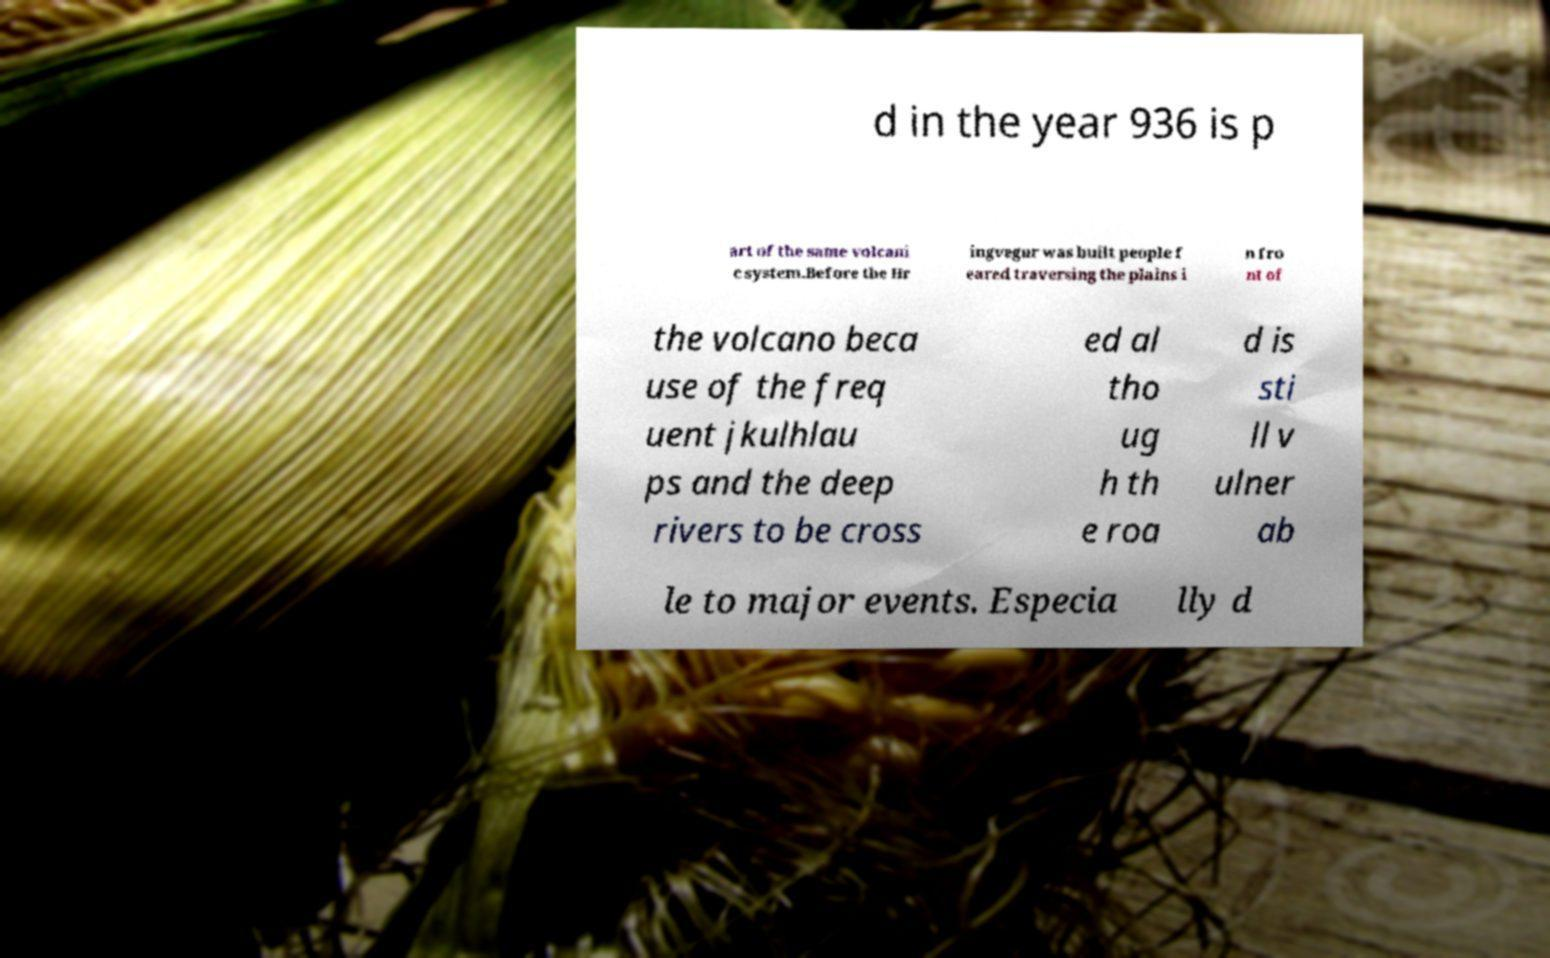Can you read and provide the text displayed in the image?This photo seems to have some interesting text. Can you extract and type it out for me? d in the year 936 is p art of the same volcani c system.Before the Hr ingvegur was built people f eared traversing the plains i n fro nt of the volcano beca use of the freq uent jkulhlau ps and the deep rivers to be cross ed al tho ug h th e roa d is sti ll v ulner ab le to major events. Especia lly d 